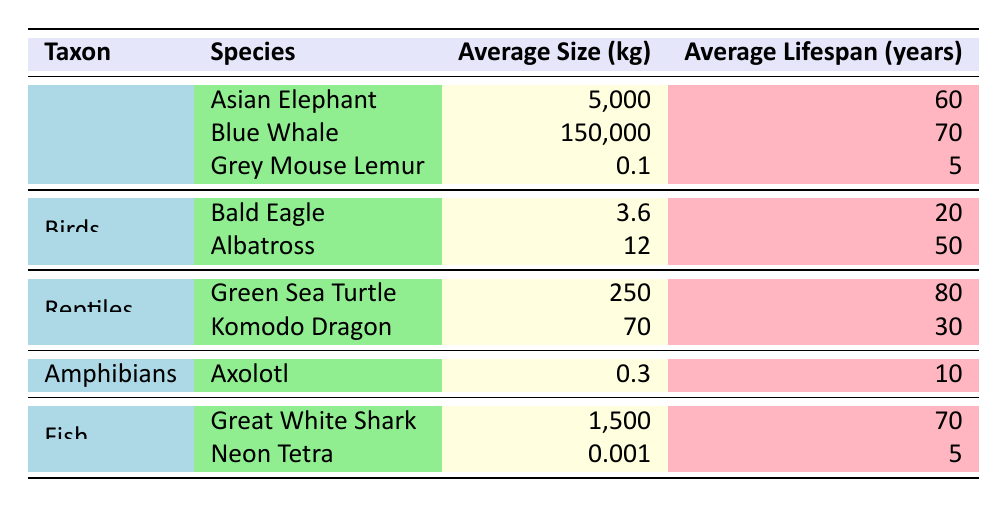What is the average size of the Asian Elephant? The table lists the Asian Elephant under the Mammals taxon, and its average size is clearly mentioned as 5,000 kg.
Answer: 5,000 kg Which species has the longest average lifespan? From the table, the Green Sea Turtle has the longest average lifespan at 80 years, compared to the other species listed.
Answer: 80 years If we take the average lifespan of all the mammals listed, what is the result? The average lifespan for mammals includes the Asian Elephant (60 years), Blue Whale (70 years), and Grey Mouse Lemur (5 years). To calculate: (60 + 70 + 5) / 3 = 135 / 3 = 45 years.
Answer: 45 years Is the average lifespan of the Komodo Dragon greater than 40 years? Referring to the table, the average lifespan of the Komodo Dragon is 30 years, which is not greater than 40 years.
Answer: No What is the total average size of the birds listed in the table? The average sizes for the birds are the Bald Eagle (3.6 kg) and the Albatross (12 kg). To find the total average size: 3.6 + 12 = 15.6 kg.
Answer: 15.6 kg Which taxon has the highest average size? Looking at the table, the taxon Mammals (represented by the Blue Whale with an average size of 150,000 kg) has the highest average size when compared to Birds, Reptiles, Amphibians, and Fish.
Answer: Mammals What is the average lifespan of reptiles? The average lifespan for reptiles can be calculated by considering the Green Sea Turtle (80 years) and the Komodo Dragon (30 years). The average lifespan would be: (80 + 30) / 2 = 110 / 2 = 55 years.
Answer: 55 years Is it true that all fish listed have an average lifespan of 10 years or more? The table shows that the Great White Shark has an average lifespan of 70 years, while the Neon Tetra has an average lifespan of only 5 years. Therefore, not all fish meet the criteria.
Answer: No How does the average lifespan of the Great White Shark compare to that of the Grey Mouse Lemur? The Great White Shark has an average lifespan of 70 years, while the Grey Mouse Lemur has an average lifespan of only 5 years. Thus, the Great White Shark has a significantly longer lifespan.
Answer: Great White Shark has a longer lifespan 